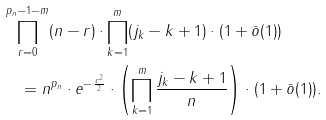Convert formula to latex. <formula><loc_0><loc_0><loc_500><loc_500>& \prod ^ { p _ { n } - 1 - m } _ { r = 0 } ( n - r ) \cdot \prod ^ { m } _ { k = 1 } ( j _ { k } - k + 1 ) \cdot ( 1 + \bar { o } ( 1 ) ) \\ & \quad = n ^ { p _ { n } } \cdot e ^ { - \frac { c ^ { 2 } } { 2 } } \cdot \left ( \prod ^ { m } _ { k = 1 } \frac { j _ { k } - k + 1 } { n } \right ) \cdot ( 1 + \bar { o } ( 1 ) ) .</formula> 